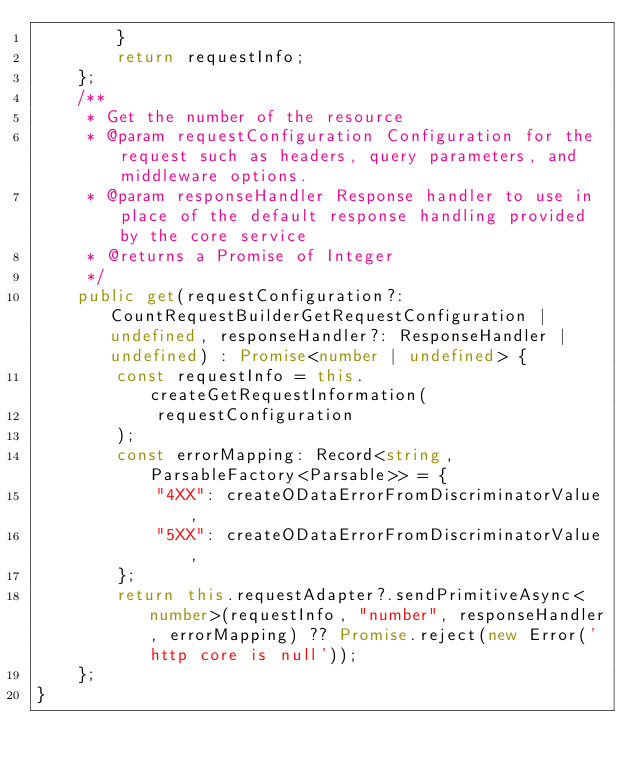Convert code to text. <code><loc_0><loc_0><loc_500><loc_500><_TypeScript_>        }
        return requestInfo;
    };
    /**
     * Get the number of the resource
     * @param requestConfiguration Configuration for the request such as headers, query parameters, and middleware options.
     * @param responseHandler Response handler to use in place of the default response handling provided by the core service
     * @returns a Promise of Integer
     */
    public get(requestConfiguration?: CountRequestBuilderGetRequestConfiguration | undefined, responseHandler?: ResponseHandler | undefined) : Promise<number | undefined> {
        const requestInfo = this.createGetRequestInformation(
            requestConfiguration
        );
        const errorMapping: Record<string, ParsableFactory<Parsable>> = {
            "4XX": createODataErrorFromDiscriminatorValue,
            "5XX": createODataErrorFromDiscriminatorValue,
        };
        return this.requestAdapter?.sendPrimitiveAsync<number>(requestInfo, "number", responseHandler, errorMapping) ?? Promise.reject(new Error('http core is null'));
    };
}
</code> 